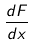Convert formula to latex. <formula><loc_0><loc_0><loc_500><loc_500>\frac { d F } { d x }</formula> 